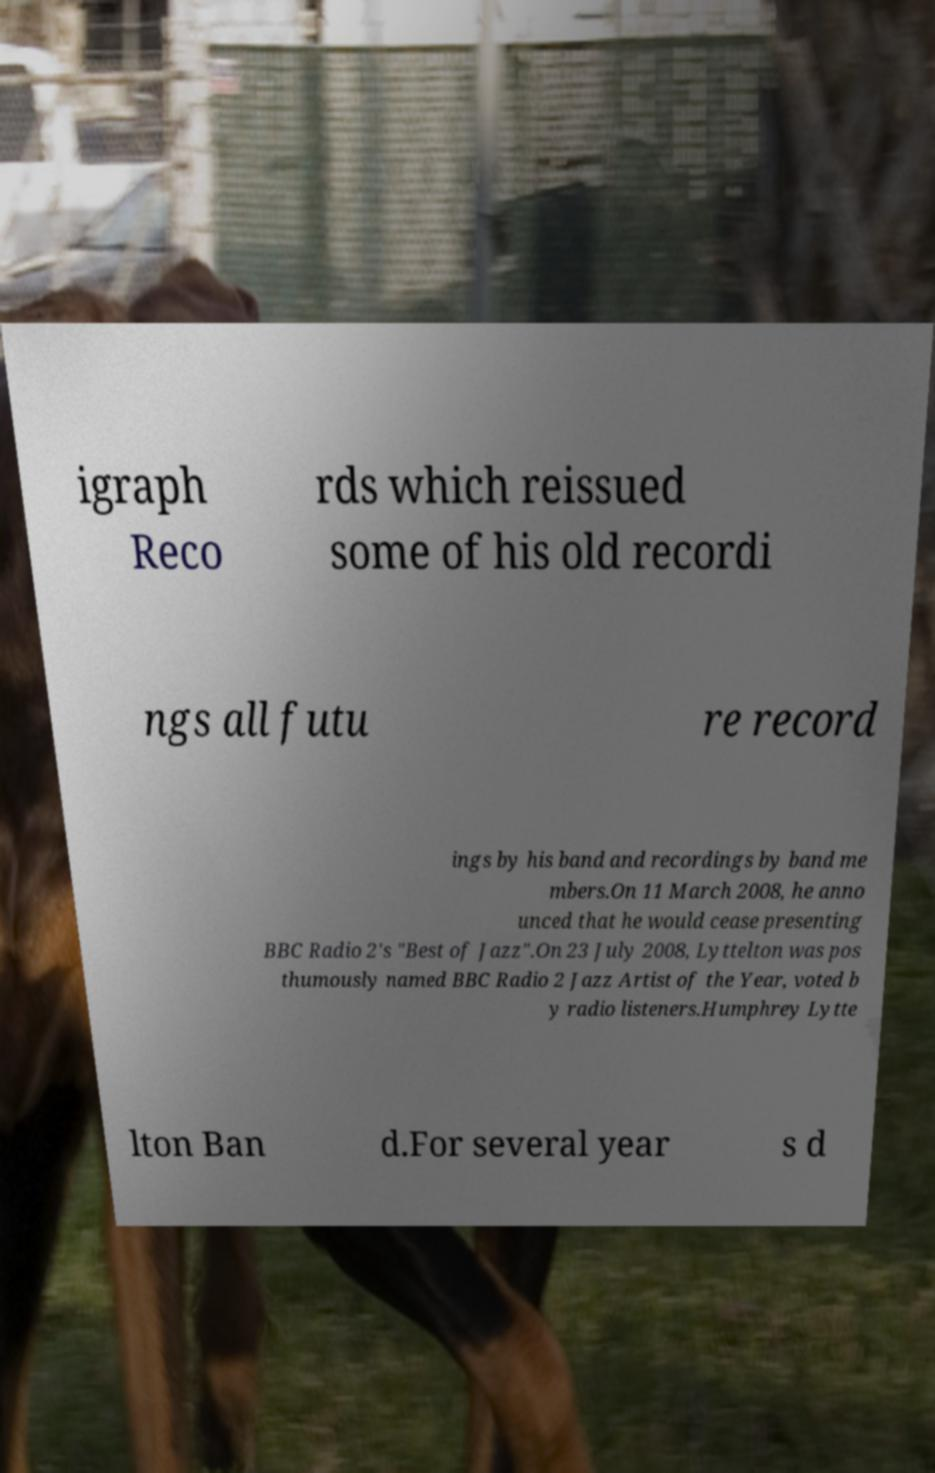Could you extract and type out the text from this image? igraph Reco rds which reissued some of his old recordi ngs all futu re record ings by his band and recordings by band me mbers.On 11 March 2008, he anno unced that he would cease presenting BBC Radio 2's "Best of Jazz".On 23 July 2008, Lyttelton was pos thumously named BBC Radio 2 Jazz Artist of the Year, voted b y radio listeners.Humphrey Lytte lton Ban d.For several year s d 